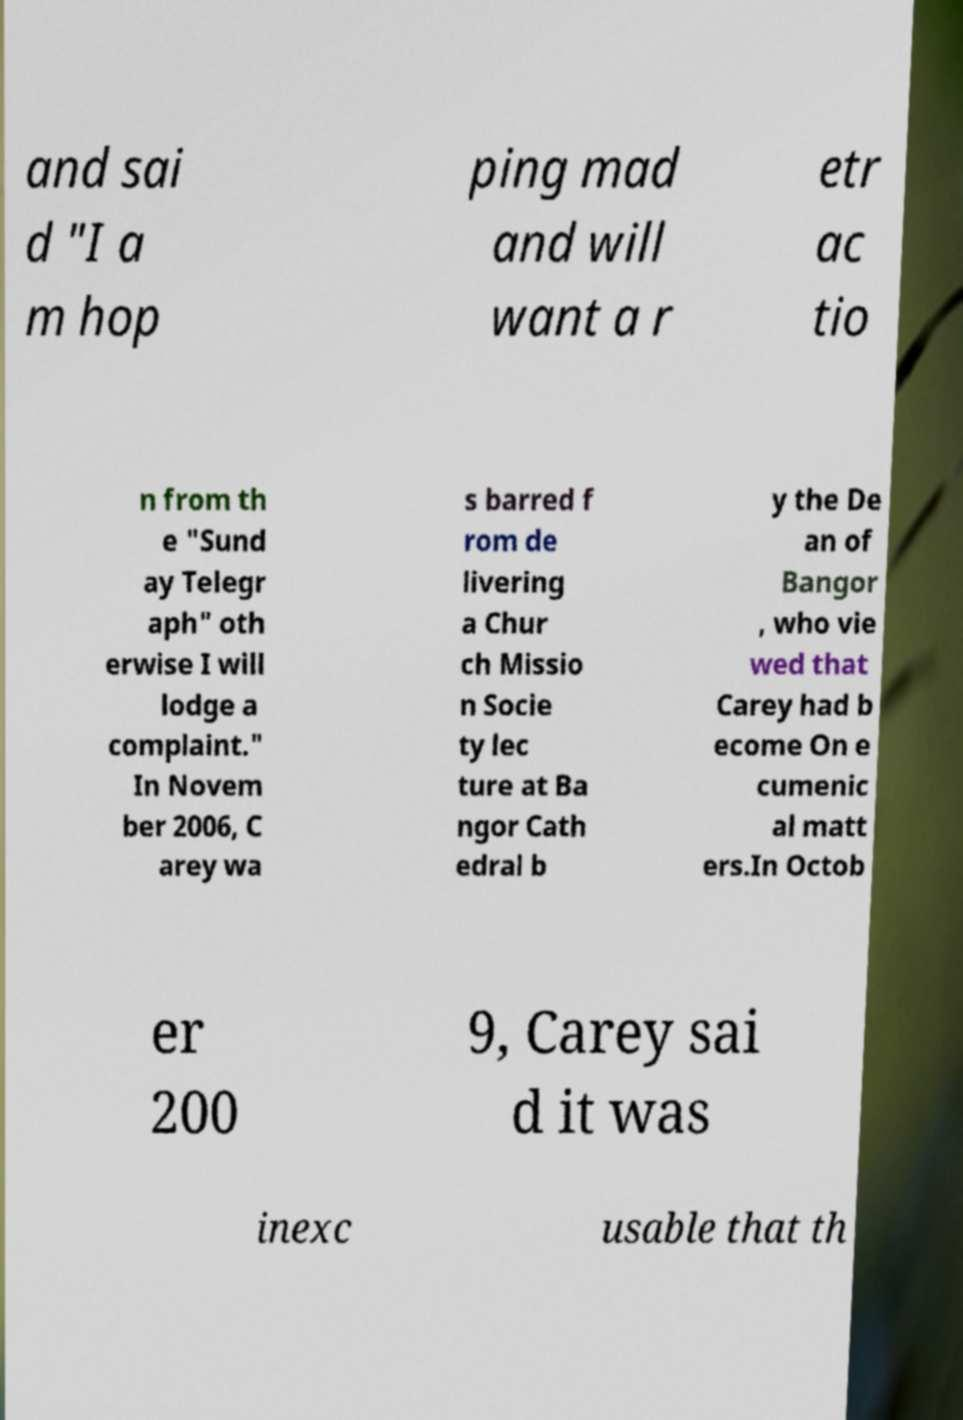There's text embedded in this image that I need extracted. Can you transcribe it verbatim? and sai d "I a m hop ping mad and will want a r etr ac tio n from th e "Sund ay Telegr aph" oth erwise I will lodge a complaint." In Novem ber 2006, C arey wa s barred f rom de livering a Chur ch Missio n Socie ty lec ture at Ba ngor Cath edral b y the De an of Bangor , who vie wed that Carey had b ecome On e cumenic al matt ers.In Octob er 200 9, Carey sai d it was inexc usable that th 